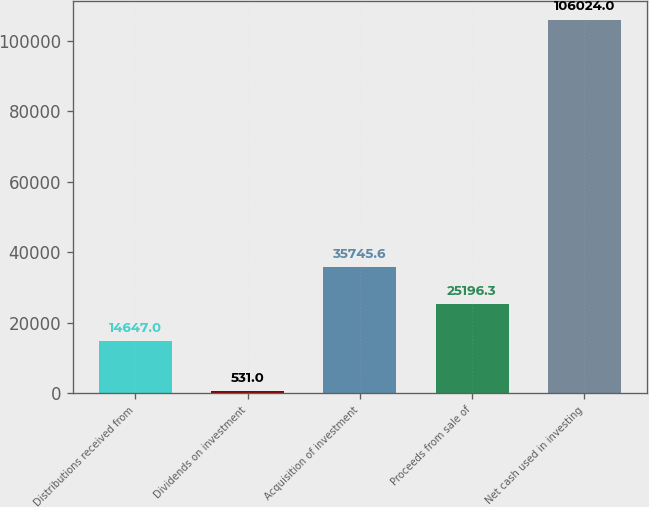<chart> <loc_0><loc_0><loc_500><loc_500><bar_chart><fcel>Distributions received from<fcel>Dividends on investment<fcel>Acquisition of investment<fcel>Proceeds from sale of<fcel>Net cash used in investing<nl><fcel>14647<fcel>531<fcel>35745.6<fcel>25196.3<fcel>106024<nl></chart> 